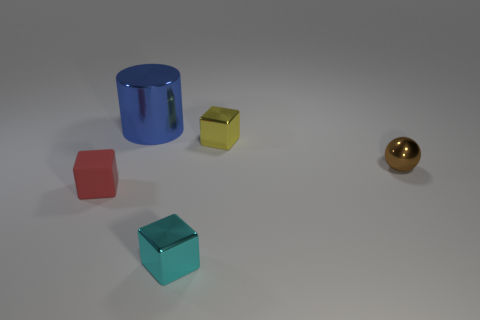There is a metallic object that is to the left of the tiny cyan thing; is it the same shape as the small rubber object?
Keep it short and to the point. No. There is a small metal object that is in front of the small shiny object right of the small object that is behind the metallic ball; what shape is it?
Offer a terse response. Cube. What is the thing that is in front of the tiny brown metal ball and to the right of the small red block made of?
Offer a very short reply. Metal. Is the number of things less than the number of large cylinders?
Ensure brevity in your answer.  No. Do the small red rubber thing and the small thing to the right of the tiny yellow metal thing have the same shape?
Make the answer very short. No. Does the metallic cube that is behind the brown metal thing have the same size as the blue shiny thing?
Your response must be concise. No. What is the shape of the red matte thing that is the same size as the cyan block?
Provide a short and direct response. Cube. Does the large thing have the same shape as the cyan thing?
Offer a very short reply. No. What number of other tiny red rubber things have the same shape as the small red object?
Give a very brief answer. 0. How many tiny cubes are to the right of the tiny brown object?
Your answer should be very brief. 0. 